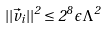<formula> <loc_0><loc_0><loc_500><loc_500>| | \vec { v } _ { i } | | ^ { 2 } \leq 2 ^ { 8 } \, \epsilon \Lambda ^ { 2 }</formula> 